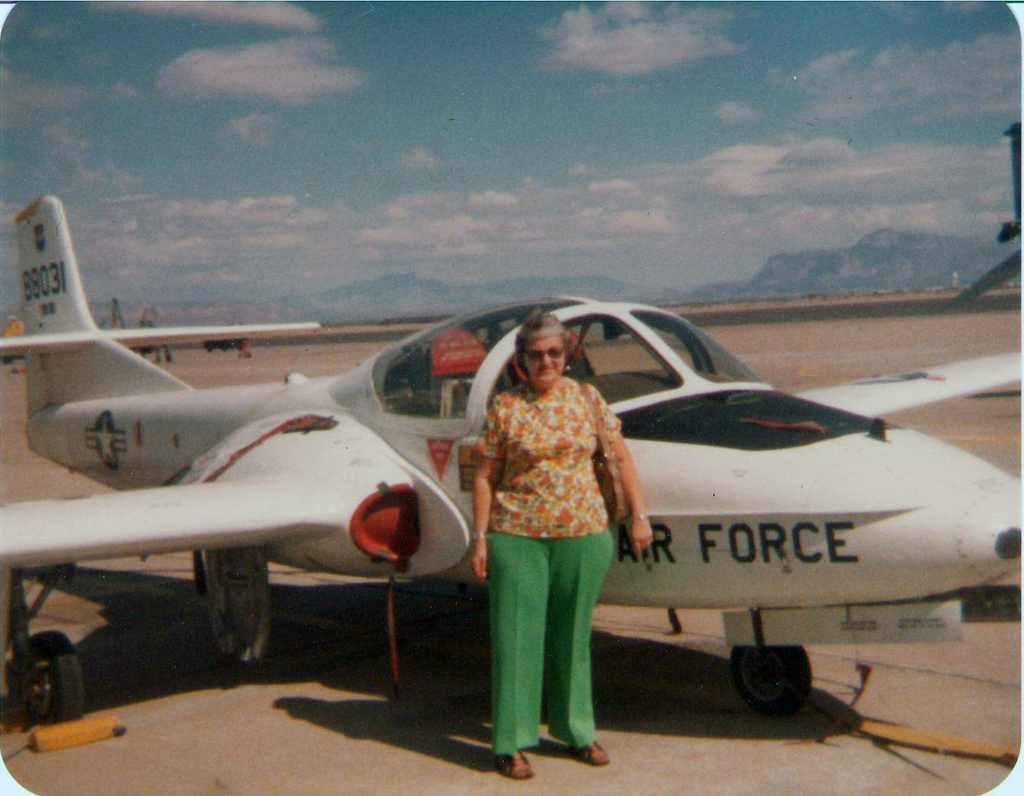Can you describe the setting and time period this photo might have been taken? This photo likely dates back to the 1970s to 1980s, considering the fashion style and the design of the T-37 Tweet. The location appears to be a dry, flat airfield likely situated in the Southwestern United States, as indicated by the mountainous background and the clear, expansive sky. 